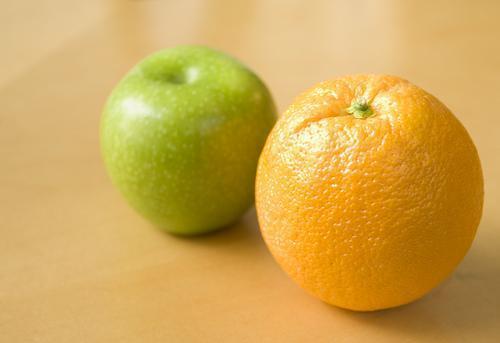Does the caption "The apple is at the right side of the orange." correctly depict the image?
Answer yes or no. No. 